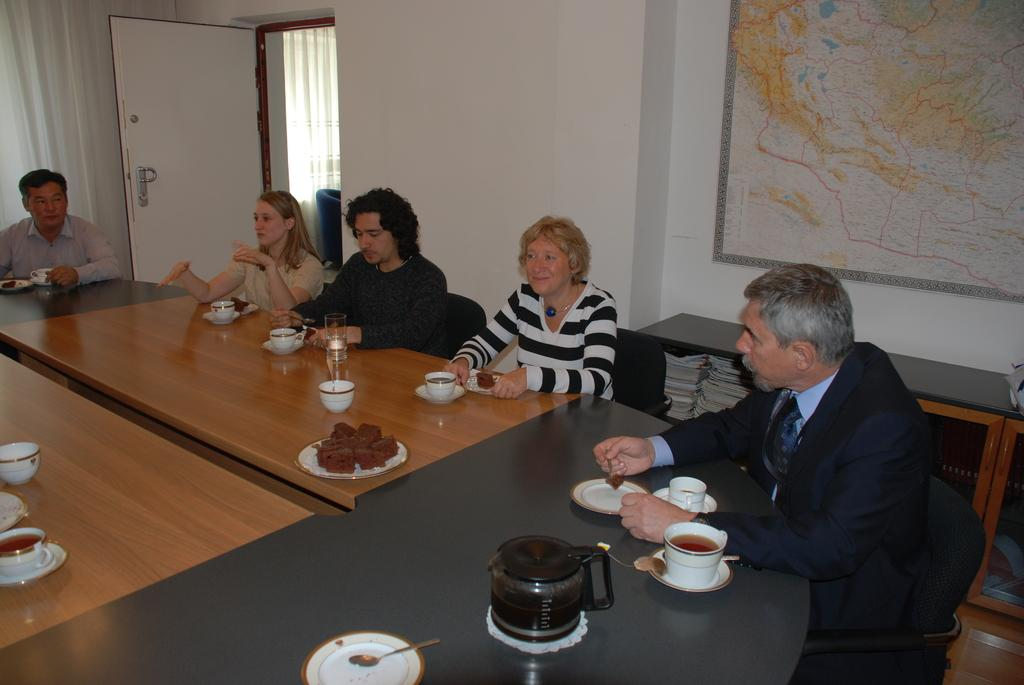What are the people in the image doing? The people in the image are sitting on chairs. What is present on the table in the image? There is a cup, a soccer ball, and a plate on the table. What is on the plate? There is a cake in the plate. What type of bread is being used to extinguish the fire in the image? There is no fire present in the image, and therefore no bread is being used to extinguish it. 